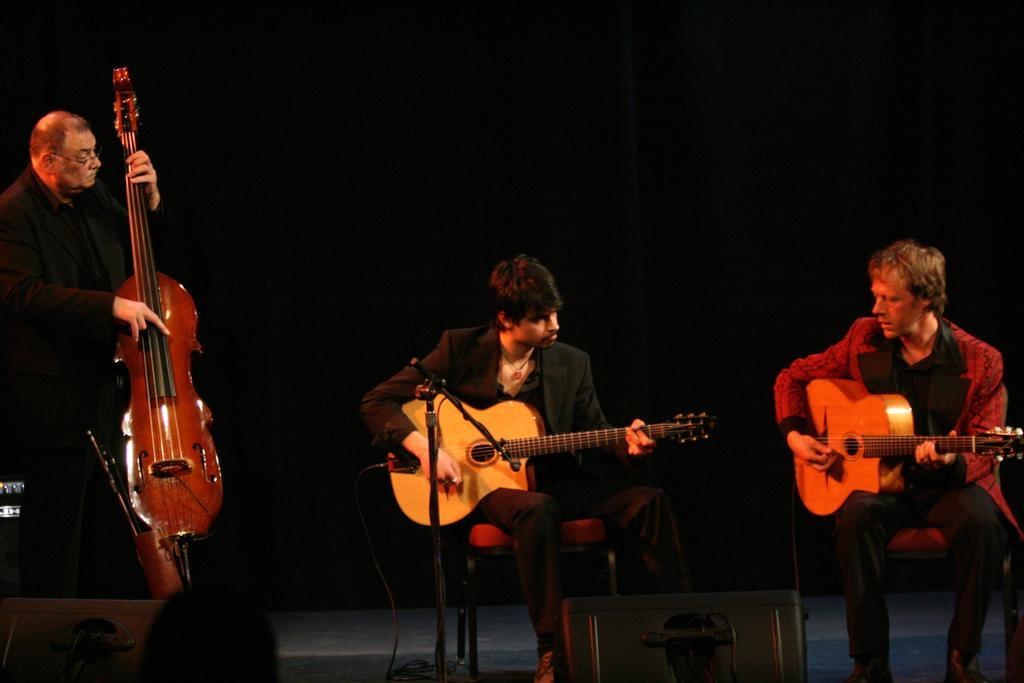Could you give a brief overview of what you see in this image? In this image I can see three people where two of them are sitting and holding guitars and here one is standing and holding a musical instrument. I can also see a mic in front of him. 